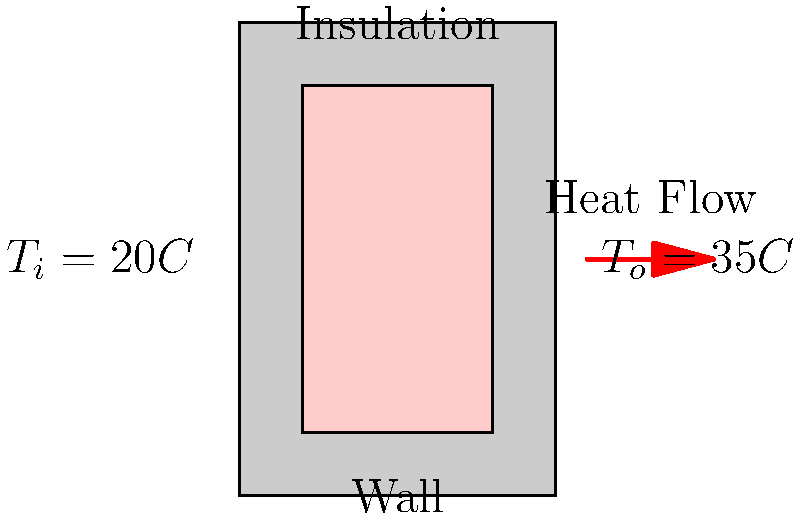As a professional Marathi folk singer, you're planning to set up a recording studio in Mumbai. The studio wall consists of a 20 cm thick concrete wall with 10 cm of fiberglass insulation. If the indoor temperature is maintained at 20°C and the outdoor temperature reaches 35°C on a hot summer day, calculate the rate of heat transfer per square meter through the studio wall. Given:
- Thermal conductivity of concrete: $k_c = 1.7 \, W/(m \cdot K)$
- Thermal conductivity of fiberglass: $k_f = 0.04 \, W/(m \cdot K)$ To solve this problem, we'll use the concept of thermal resistance in series and the heat transfer equation. Let's break it down step-by-step:

1) The total thermal resistance is the sum of the resistances of concrete and fiberglass:
   $R_{total} = R_{concrete} + R_{fiberglass}$

2) Thermal resistance is calculated as $R = \frac{L}{k}$, where $L$ is thickness and $k$ is thermal conductivity:
   $R_{concrete} = \frac{0.20 \, m}{1.7 \, W/(m \cdot K)} = 0.1176 \, (m^2 \cdot K)/W$
   $R_{fiberglass} = \frac{0.10 \, m}{0.04 \, W/(m \cdot K)} = 2.5 \, (m^2 \cdot K)/W$

3) Total thermal resistance:
   $R_{total} = 0.1176 + 2.5 = 2.6176 \, (m^2 \cdot K)/W$

4) The heat transfer rate per unit area is given by:
   $q = \frac{\Delta T}{R_{total}}$

   Where $\Delta T$ is the temperature difference (35°C - 20°C = 15°C)

5) Substituting the values:
   $q = \frac{15 \, K}{2.6176 \, (m^2 \cdot K)/W} = 5.73 \, W/m^2$

Therefore, the rate of heat transfer per square meter through the studio wall is approximately 5.73 W/m².
Answer: 5.73 W/m² 